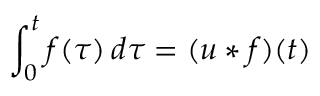Convert formula to latex. <formula><loc_0><loc_0><loc_500><loc_500>\int _ { 0 } ^ { t } f ( \tau ) \, d \tau = ( u * f ) ( t )</formula> 